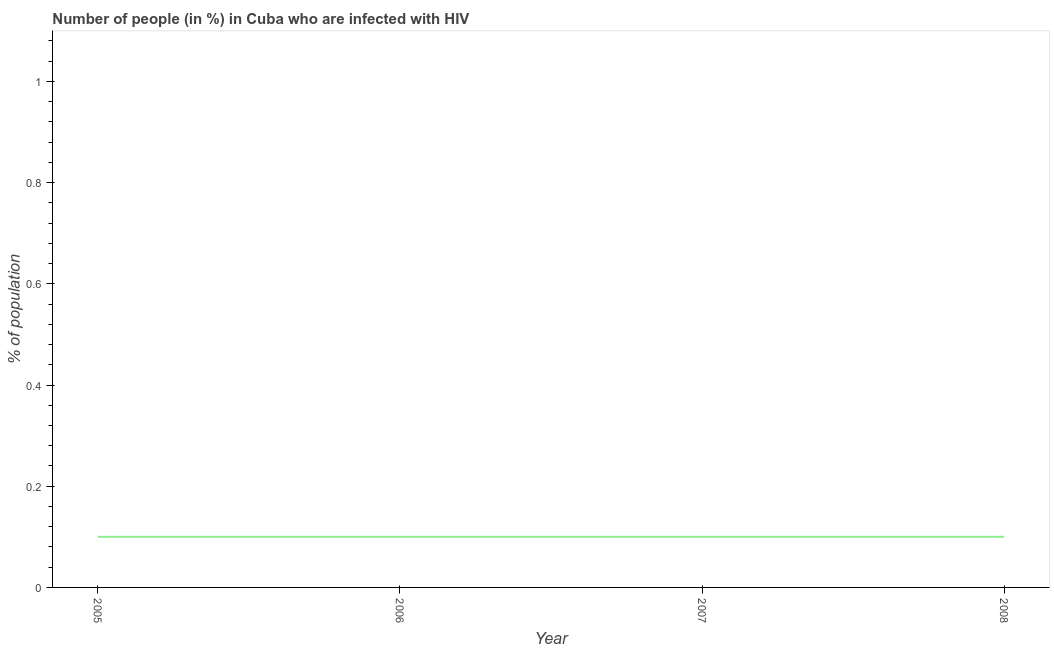What is the number of people infected with hiv in 2006?
Your answer should be very brief. 0.1. Across all years, what is the maximum number of people infected with hiv?
Provide a short and direct response. 0.1. What is the difference between the number of people infected with hiv in 2007 and 2008?
Keep it short and to the point. 0. In how many years, is the number of people infected with hiv greater than 0.32 %?
Offer a very short reply. 0. Is the number of people infected with hiv in 2006 less than that in 2008?
Give a very brief answer. No. In how many years, is the number of people infected with hiv greater than the average number of people infected with hiv taken over all years?
Your answer should be compact. 0. Does the number of people infected with hiv monotonically increase over the years?
Your response must be concise. No. How many years are there in the graph?
Your answer should be very brief. 4. Does the graph contain any zero values?
Provide a succinct answer. No. Does the graph contain grids?
Your answer should be very brief. No. What is the title of the graph?
Your response must be concise. Number of people (in %) in Cuba who are infected with HIV. What is the label or title of the X-axis?
Offer a terse response. Year. What is the label or title of the Y-axis?
Your response must be concise. % of population. What is the % of population of 2005?
Provide a succinct answer. 0.1. What is the difference between the % of population in 2005 and 2006?
Offer a very short reply. 0. What is the difference between the % of population in 2005 and 2007?
Ensure brevity in your answer.  0. What is the difference between the % of population in 2005 and 2008?
Keep it short and to the point. 0. What is the difference between the % of population in 2007 and 2008?
Your answer should be very brief. 0. What is the ratio of the % of population in 2005 to that in 2006?
Make the answer very short. 1. What is the ratio of the % of population in 2005 to that in 2008?
Provide a succinct answer. 1. What is the ratio of the % of population in 2006 to that in 2008?
Your answer should be very brief. 1. 